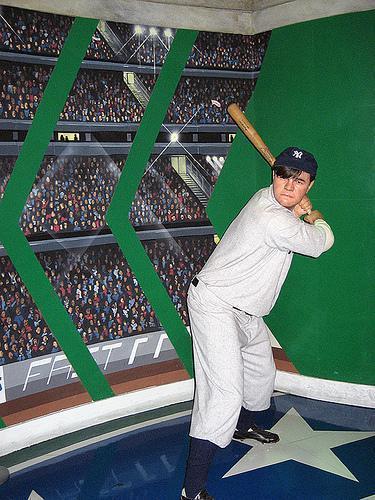How many bats is babe Ruth holding?
Give a very brief answer. 1. How many people are there?
Give a very brief answer. 1. 